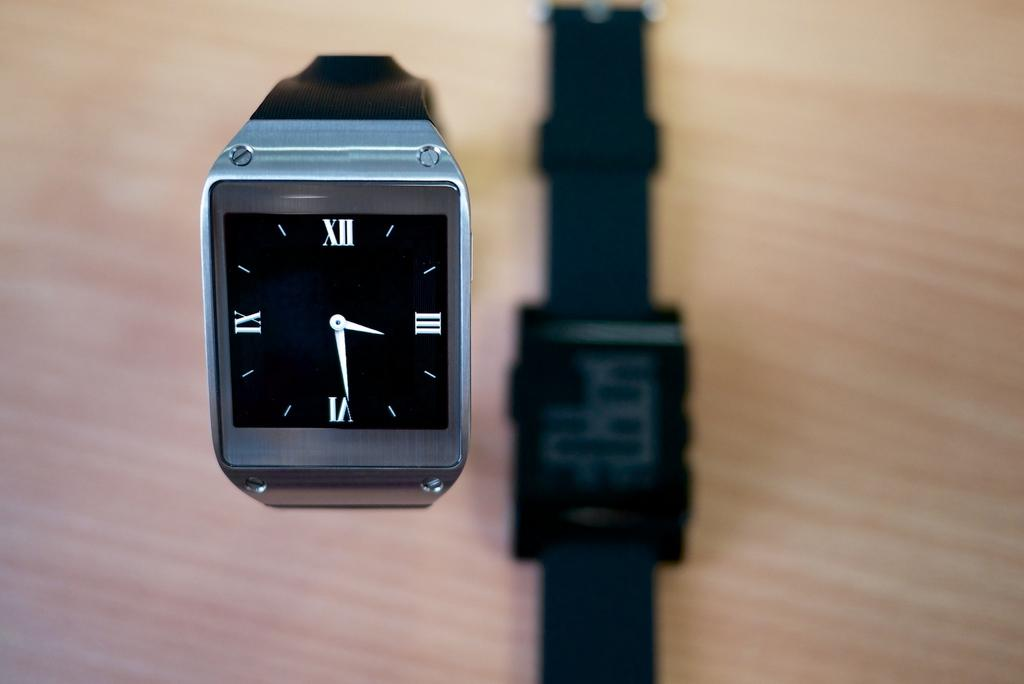<image>
Share a concise interpretation of the image provided. The black face of a smart watch whose time reads 3:29 on its face. 